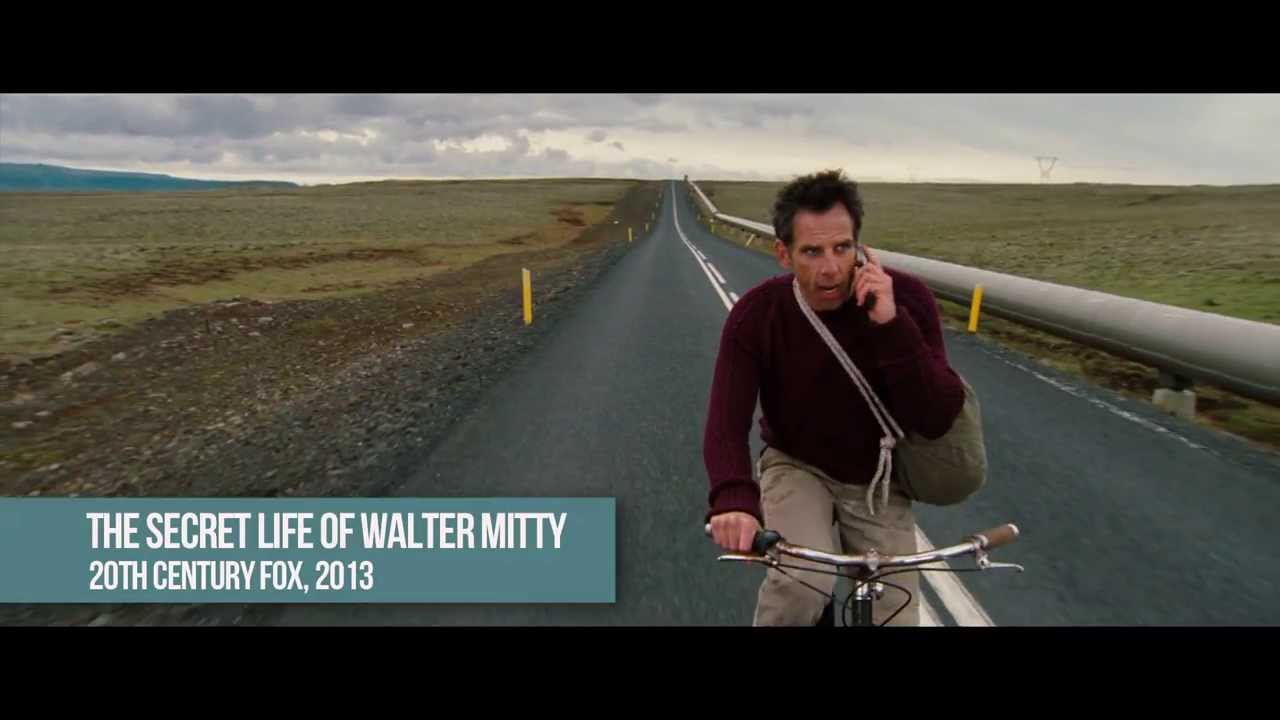Describe the scene as if you were painting it, focusing on brushstrokes, colors, and textures. With broad, sweeping strokes of muted grays and blues, the sky is painted to capture the melancholic, overcast atmosphere. The barren landscape, a canvas of ochre and olive hues, is textured with coarse, rugged brushstrokes to reflect its desolation and roughness. The long, straight road is a stark, uninterrupted line of dark asphalt, skillfully rendered with a palette knife to convey its unyielding, arduous nature. The figure on the bicycle, in a maroon sweater, is detailed with fine, deliberate strokes that emphasize his tense posture and worried expression, the only vibrant touch in an otherwise somber tableau. The overall composition harmoniously blends the elements to portray a scene rich with narrative and emotion. What details would you emphasize to convey the urgency in the scene? To convey the urgency, I would emphasize the man’s forward-leaning posture and the tensed muscles in his legs and arms, suggesting his desperate haste. I would also highlight the fierce, determined expression on his face, meticulously detailing the lines of worry and concentration. The blurred motion lines of the bicycle’s wheels would add a sense of speed and immediacy. Additionally, the darkening clouds overhead, painted with rapid, swirling strokes, would serve to heighten the sense of impending danger, while the empty, featureless expanse on either side of the road would underscore the isolation and urgency of his solitary journey. 